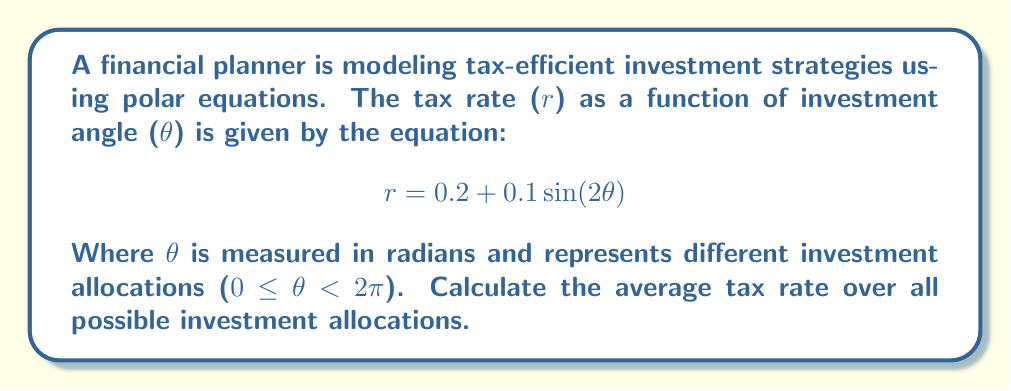Provide a solution to this math problem. To find the average tax rate over all possible investment allocations, we need to integrate the given function over the full range of θ and divide by the total range. Here's the step-by-step process:

1) The average value of a function f(θ) over an interval [a, b] is given by:

   $$\text{Average} = \frac{1}{b-a}\int_{a}^{b} f(\theta) d\theta$$

2) In our case, a = 0, b = 2π, and f(θ) = 0.2 + 0.1sin(2θ). So we have:

   $$\text{Average tax rate} = \frac{1}{2\pi}\int_{0}^{2\pi} (0.2 + 0.1\sin(2\theta)) d\theta$$

3) Let's solve this integral:

   $$\frac{1}{2\pi}\int_{0}^{2\pi} (0.2 + 0.1\sin(2\theta)) d\theta$$
   
   $$= \frac{1}{2\pi}\left[0.2\theta - 0.1\frac{\cos(2\theta)}{2}\right]_{0}^{2\pi}$$

4) Evaluating the integral:

   $$= \frac{1}{2\pi}\left[(0.2(2\pi) - 0.1\frac{\cos(4\pi)}{2}) - (0 - 0.1\frac{\cos(0)}{2})\right]$$

5) Simplify:

   $$= \frac{1}{2\pi}\left[0.4\pi - 0.1\frac{1}{2} + 0.1\frac{1}{2}\right] = \frac{1}{2\pi}[0.4\pi] = 0.2$$

Thus, the average tax rate over all possible investment allocations is 0.2 or 20%.
Answer: The average tax rate over all possible investment allocations is 0.2 or 20%. 